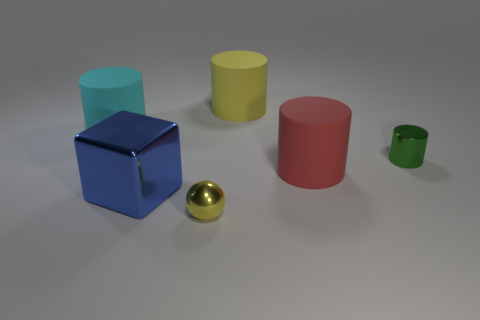What number of large matte cylinders have the same color as the metallic sphere?
Your answer should be compact. 1. There is a metal thing that is to the right of the yellow shiny sphere; does it have the same shape as the yellow rubber object?
Make the answer very short. Yes. What shape is the yellow object that is in front of the cylinder right of the large cylinder that is on the right side of the large yellow thing?
Offer a terse response. Sphere. The cyan cylinder has what size?
Offer a terse response. Large. There is a sphere that is the same material as the block; what is its color?
Your response must be concise. Yellow. How many other large things are made of the same material as the blue object?
Keep it short and to the point. 0. Do the ball and the cylinder that is behind the large cyan cylinder have the same color?
Keep it short and to the point. Yes. What is the color of the rubber cylinder behind the cylinder to the left of the cube?
Keep it short and to the point. Yellow. There is a ball that is the same size as the metal cylinder; what color is it?
Your response must be concise. Yellow. Are there any other matte things of the same shape as the big yellow object?
Ensure brevity in your answer.  Yes. 